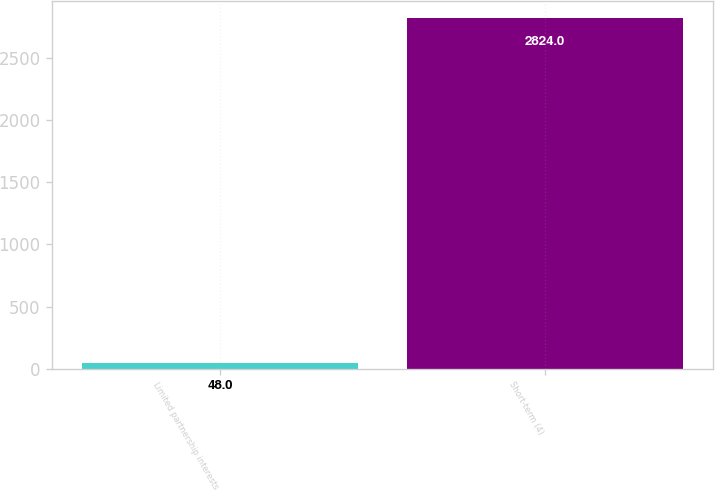Convert chart to OTSL. <chart><loc_0><loc_0><loc_500><loc_500><bar_chart><fcel>Limited partnership interests<fcel>Short-term (4)<nl><fcel>48<fcel>2824<nl></chart> 